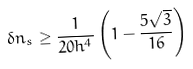Convert formula to latex. <formula><loc_0><loc_0><loc_500><loc_500>\delta n _ { s } \geq \frac { 1 } { 2 0 h ^ { 4 } } \left ( 1 - \frac { 5 \sqrt { 3 } } { 1 6 } \right )</formula> 